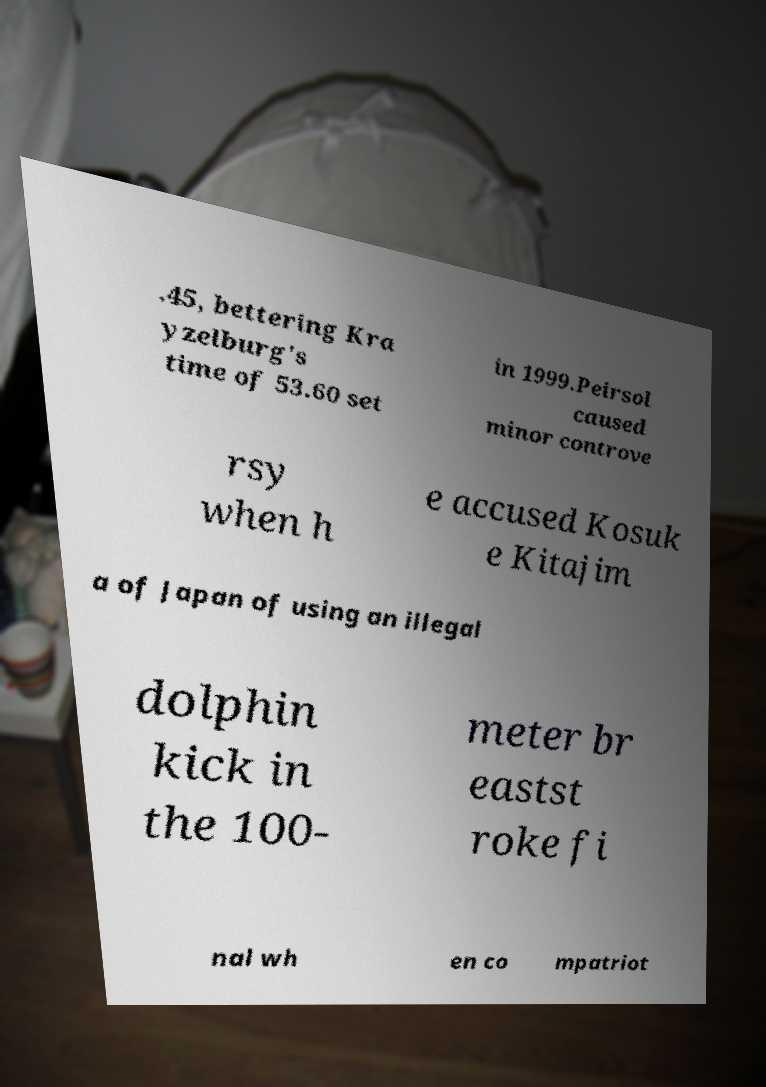Could you extract and type out the text from this image? .45, bettering Kra yzelburg's time of 53.60 set in 1999.Peirsol caused minor controve rsy when h e accused Kosuk e Kitajim a of Japan of using an illegal dolphin kick in the 100- meter br eastst roke fi nal wh en co mpatriot 